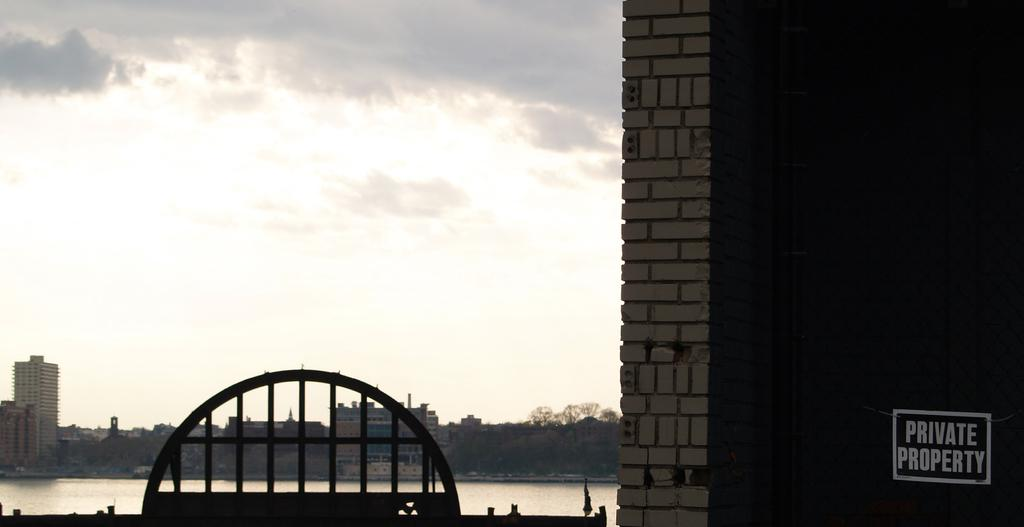<image>
Present a compact description of the photo's key features. On teh fence to the left of the brick wall, hangs a sign that says Private Property. 